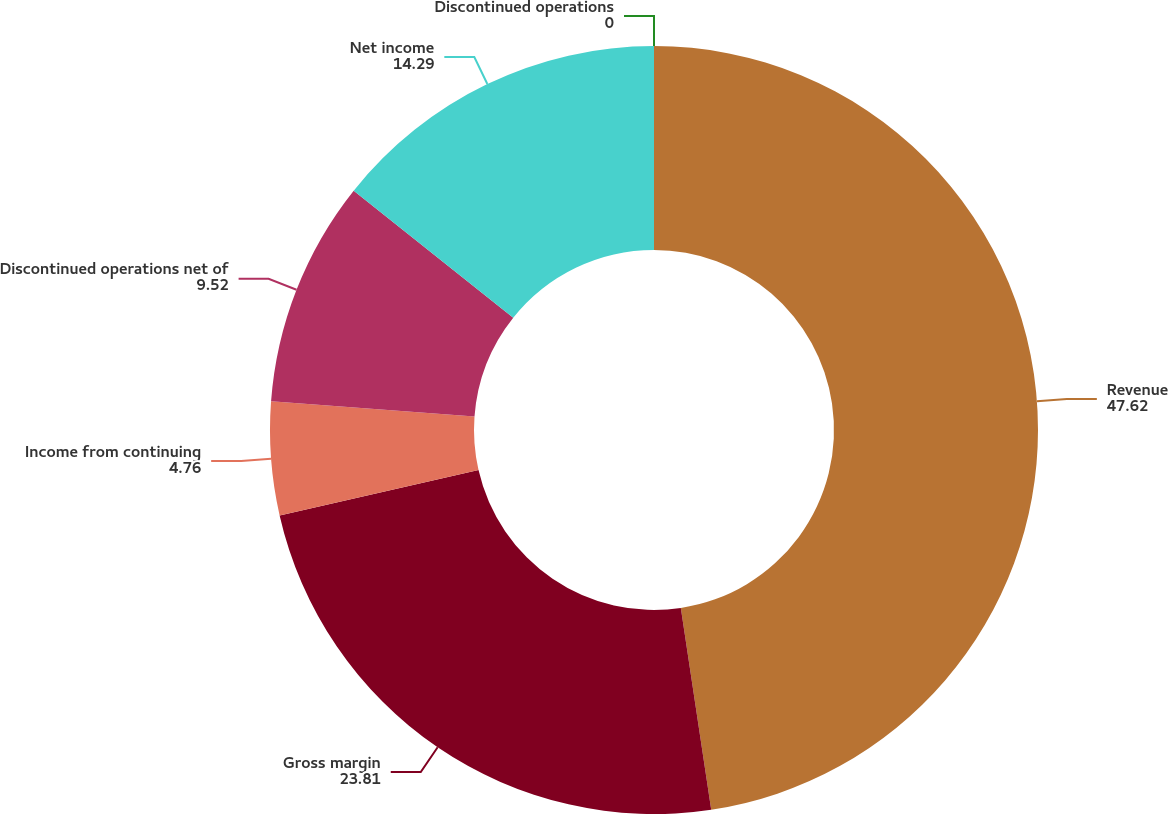<chart> <loc_0><loc_0><loc_500><loc_500><pie_chart><fcel>Revenue<fcel>Gross margin<fcel>Income from continuing<fcel>Discontinued operations net of<fcel>Net income<fcel>Discontinued operations<nl><fcel>47.62%<fcel>23.81%<fcel>4.76%<fcel>9.52%<fcel>14.29%<fcel>0.0%<nl></chart> 